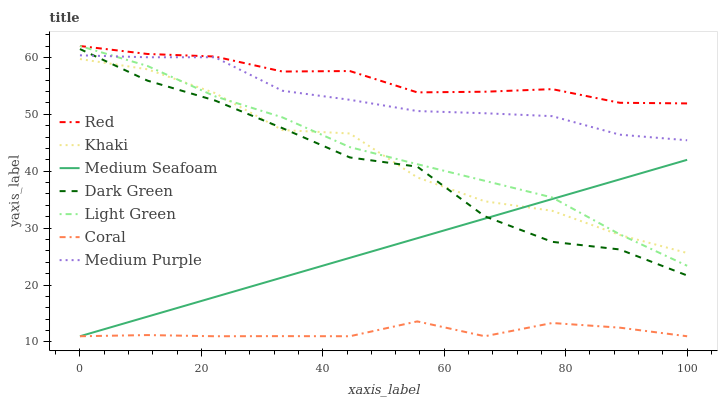Does Coral have the minimum area under the curve?
Answer yes or no. Yes. Does Red have the maximum area under the curve?
Answer yes or no. Yes. Does Medium Purple have the minimum area under the curve?
Answer yes or no. No. Does Medium Purple have the maximum area under the curve?
Answer yes or no. No. Is Medium Seafoam the smoothest?
Answer yes or no. Yes. Is Khaki the roughest?
Answer yes or no. Yes. Is Coral the smoothest?
Answer yes or no. No. Is Coral the roughest?
Answer yes or no. No. Does Coral have the lowest value?
Answer yes or no. Yes. Does Medium Purple have the lowest value?
Answer yes or no. No. Does Red have the highest value?
Answer yes or no. Yes. Does Medium Purple have the highest value?
Answer yes or no. No. Is Coral less than Light Green?
Answer yes or no. Yes. Is Medium Purple greater than Khaki?
Answer yes or no. Yes. Does Medium Seafoam intersect Coral?
Answer yes or no. Yes. Is Medium Seafoam less than Coral?
Answer yes or no. No. Is Medium Seafoam greater than Coral?
Answer yes or no. No. Does Coral intersect Light Green?
Answer yes or no. No. 